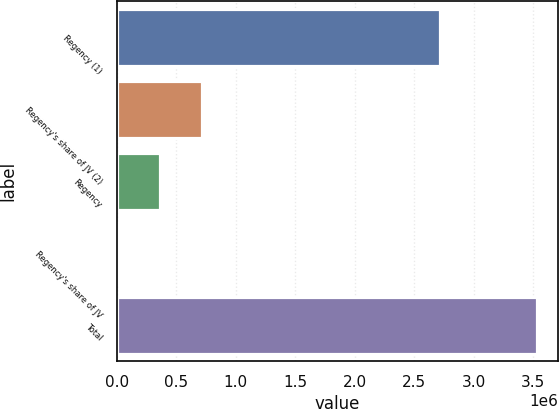Convert chart to OTSL. <chart><loc_0><loc_0><loc_500><loc_500><bar_chart><fcel>Regency (1)<fcel>Regency's share of JV (2)<fcel>Regency<fcel>Regency's share of JV<fcel>Total<nl><fcel>2.71233e+06<fcel>715288<fcel>363275<fcel>11262<fcel>3.53139e+06<nl></chart> 